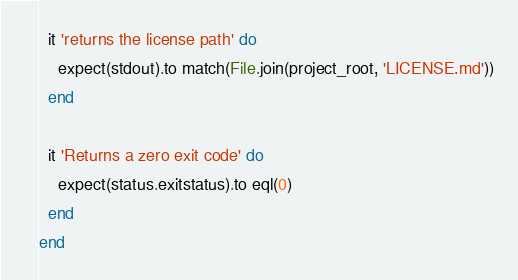<code> <loc_0><loc_0><loc_500><loc_500><_Ruby_>  it 'returns the license path' do
    expect(stdout).to match(File.join(project_root, 'LICENSE.md'))
  end

  it 'Returns a zero exit code' do
    expect(status.exitstatus).to eql(0)
  end
end
</code> 